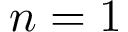<formula> <loc_0><loc_0><loc_500><loc_500>n = 1</formula> 